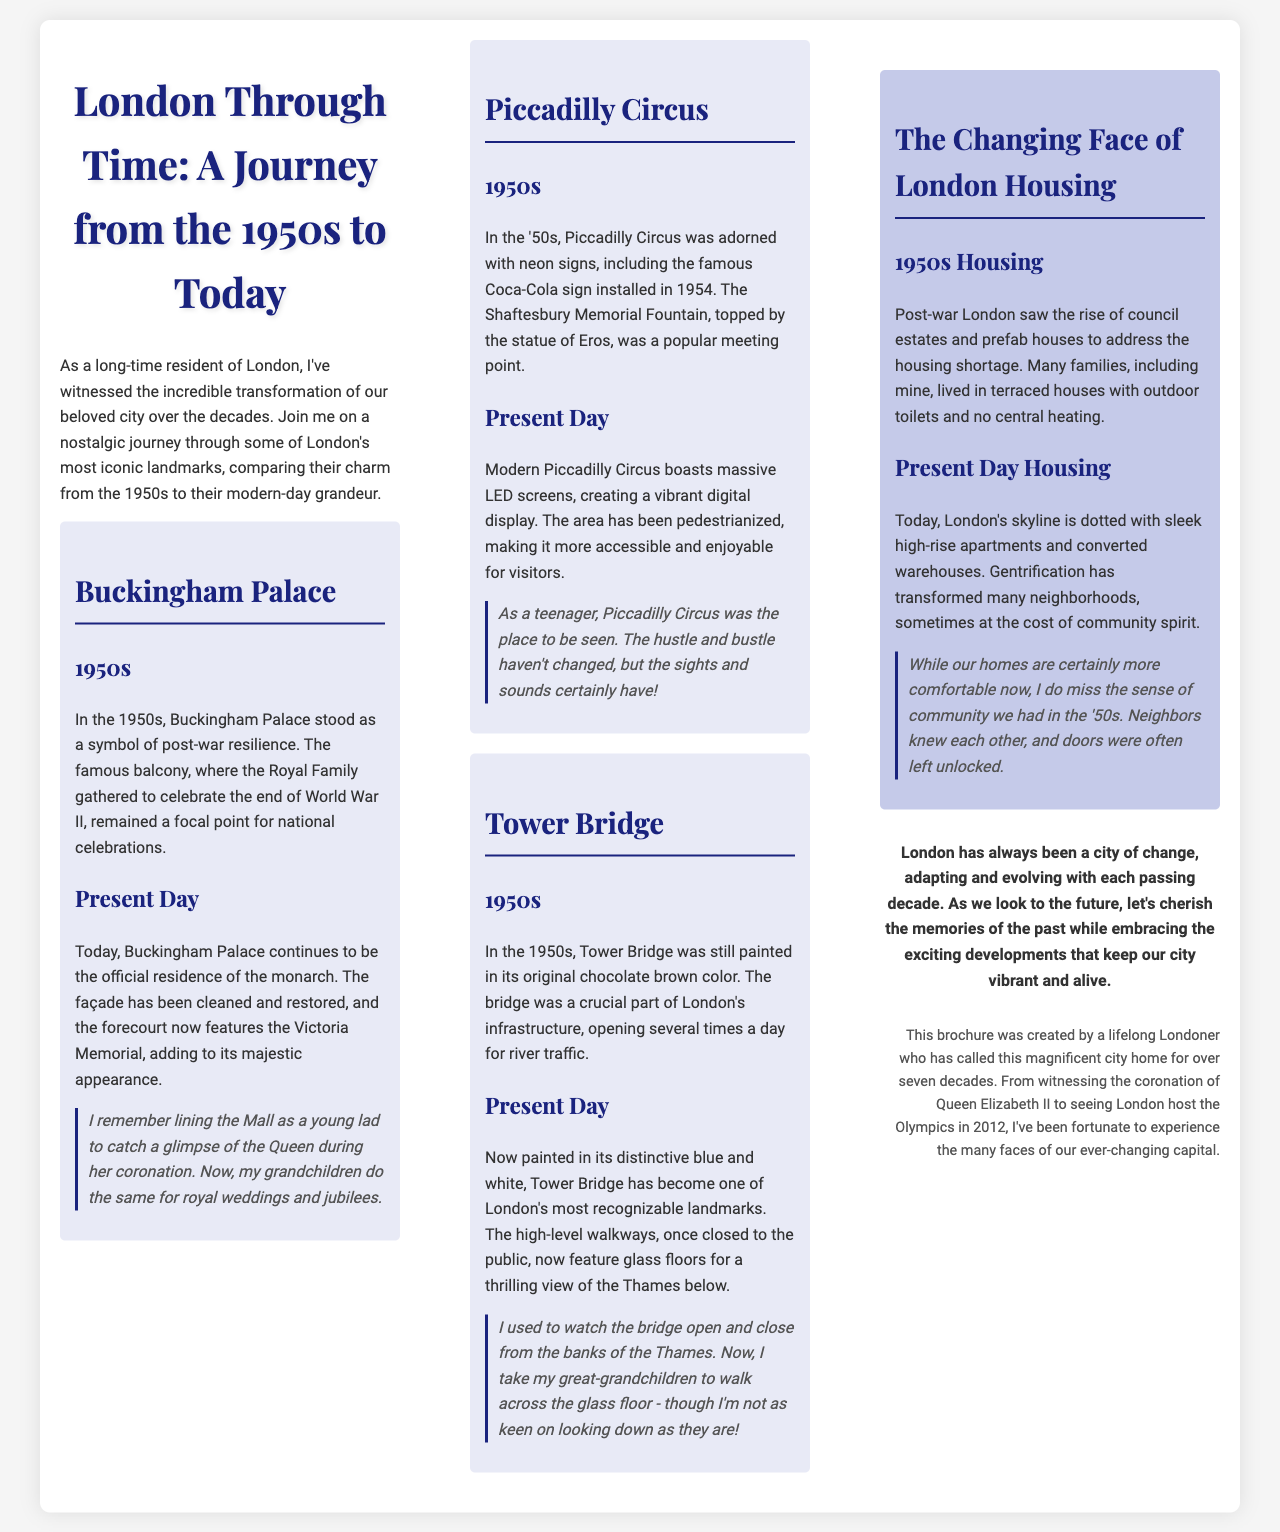What is the title of the brochure? The title is clearly stated at the top of the document, reflecting the content about London's history.
Answer: London Through Time: A Journey from the 1950s to Today Who is the author of the brochure? The section at the end identifies the creator of the brochure.
Answer: A lifelong Londoner What iconic landmark features the Victoria Memorial in its forecourt? The document specifically mentions this landmark in the context of modernization and its historical significance.
Answer: Buckingham Palace In which decade was the famous Coca-Cola sign installed at Piccadilly Circus? The 1950s are highlighted as the period of this significant installation in the text.
Answer: 1950s What is the color of Tower Bridge's current paint? The document describes the modern appearance of Tower Bridge, highlighting its distinctive colors.
Answer: Blue and white What significant change in housing occurred post-war in the 1950s? The brochure discusses the introduction of specific housing types during that period.
Answer: Council estates How does the author feel about the sense of community in the 1950s compared to now? The personal reflections section conveys the author's nostalgia regarding community spirit over the decades.
Answer: Miss it What major change has happened to Piccadilly Circus today compared to the 1950s? The document contrasts the past and present visuals, emphasizing a significant aspect of modern development.
Answer: Pedestrianized 